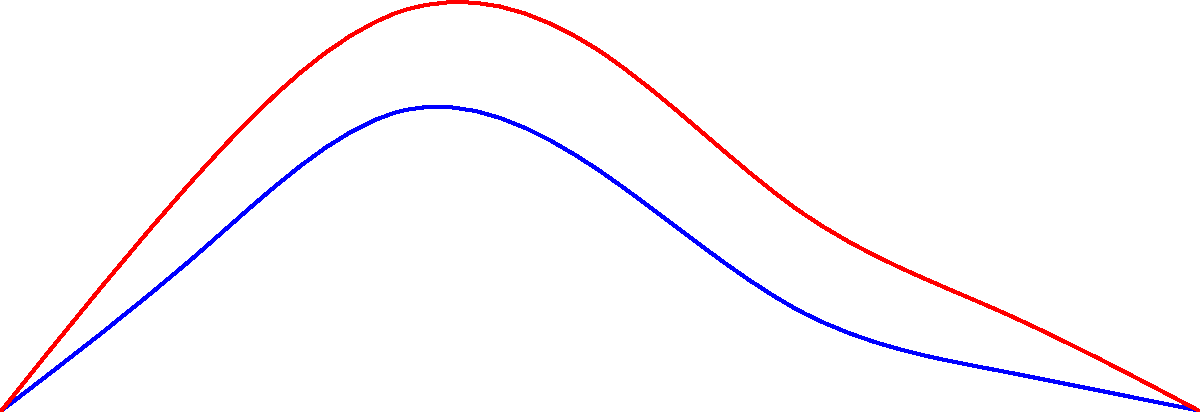Based on the graph comparing gait patterns, what key difference can be observed between Buddhist monks and average individuals in terms of vertical displacement during walking? To answer this question, let's analyze the graph step-by-step:

1. The graph shows two curves: blue for Buddhist monks and red for average individuals.
2. The x-axis represents time in seconds, while the y-axis represents vertical displacement in centimeters.
3. Both curves follow a similar sinusoidal pattern, representing the up-and-down motion during walking.
4. The key difference lies in the amplitude of these curves:
   a. The red curve (average individuals) has a higher peak, reaching about 2.0 cm.
   b. The blue curve (Buddhist monks) has a lower peak, reaching about 1.5 cm.
5. This difference in amplitude indicates that:
   a. Average individuals have a greater vertical displacement during their gait cycle.
   b. Buddhist monks have a smaller vertical displacement during their gait cycle.
6. A smaller vertical displacement suggests:
   a. A more stable and efficient walking pattern.
   b. Less energy expenditure during walking.
   c. Possibly a result of mindfulness practices and body awareness cultivated through meditation.

The key difference, therefore, is that Buddhist monks demonstrate less vertical displacement in their gait compared to average individuals.
Answer: Buddhist monks show less vertical displacement in their gait. 